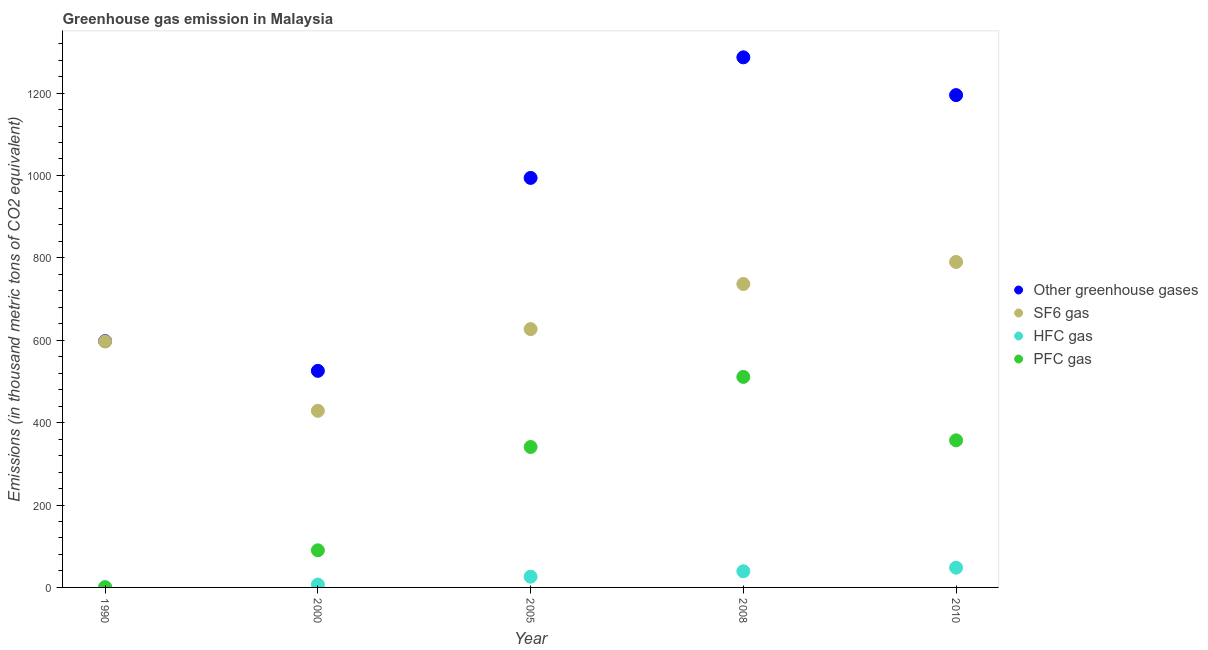What is the emission of greenhouse gases in 2005?
Your response must be concise. 994. Across all years, what is the maximum emission of greenhouse gases?
Provide a short and direct response. 1286.7. Across all years, what is the minimum emission of sf6 gas?
Your response must be concise. 428.7. What is the total emission of sf6 gas in the graph?
Your response must be concise. 3179.3. What is the difference between the emission of greenhouse gases in 2000 and that in 2010?
Keep it short and to the point. -669.3. What is the difference between the emission of hfc gas in 2000 and the emission of greenhouse gases in 2005?
Offer a terse response. -987.1. What is the average emission of hfc gas per year?
Your answer should be very brief. 24.06. In the year 2005, what is the difference between the emission of greenhouse gases and emission of hfc gas?
Offer a terse response. 967.9. What is the ratio of the emission of pfc gas in 2008 to that in 2010?
Your answer should be very brief. 1.43. What is the difference between the highest and the second highest emission of hfc gas?
Provide a short and direct response. 8.8. What is the difference between the highest and the lowest emission of hfc gas?
Your response must be concise. 47.9. Is the sum of the emission of pfc gas in 2008 and 2010 greater than the maximum emission of hfc gas across all years?
Offer a very short reply. Yes. Is it the case that in every year, the sum of the emission of pfc gas and emission of greenhouse gases is greater than the sum of emission of hfc gas and emission of sf6 gas?
Offer a very short reply. Yes. Is the emission of pfc gas strictly greater than the emission of sf6 gas over the years?
Provide a succinct answer. No. Is the emission of hfc gas strictly less than the emission of pfc gas over the years?
Your response must be concise. Yes. What is the difference between two consecutive major ticks on the Y-axis?
Provide a succinct answer. 200. Are the values on the major ticks of Y-axis written in scientific E-notation?
Your answer should be very brief. No. Does the graph contain any zero values?
Ensure brevity in your answer.  No. What is the title of the graph?
Give a very brief answer. Greenhouse gas emission in Malaysia. Does "Revenue mobilization" appear as one of the legend labels in the graph?
Keep it short and to the point. No. What is the label or title of the X-axis?
Make the answer very short. Year. What is the label or title of the Y-axis?
Give a very brief answer. Emissions (in thousand metric tons of CO2 equivalent). What is the Emissions (in thousand metric tons of CO2 equivalent) of Other greenhouse gases in 1990?
Keep it short and to the point. 597.8. What is the Emissions (in thousand metric tons of CO2 equivalent) of SF6 gas in 1990?
Offer a terse response. 597.1. What is the Emissions (in thousand metric tons of CO2 equivalent) in HFC gas in 1990?
Offer a terse response. 0.1. What is the Emissions (in thousand metric tons of CO2 equivalent) of PFC gas in 1990?
Offer a terse response. 0.6. What is the Emissions (in thousand metric tons of CO2 equivalent) of Other greenhouse gases in 2000?
Ensure brevity in your answer.  525.7. What is the Emissions (in thousand metric tons of CO2 equivalent) of SF6 gas in 2000?
Keep it short and to the point. 428.7. What is the Emissions (in thousand metric tons of CO2 equivalent) in PFC gas in 2000?
Provide a succinct answer. 90.1. What is the Emissions (in thousand metric tons of CO2 equivalent) in Other greenhouse gases in 2005?
Offer a terse response. 994. What is the Emissions (in thousand metric tons of CO2 equivalent) in SF6 gas in 2005?
Make the answer very short. 627. What is the Emissions (in thousand metric tons of CO2 equivalent) in HFC gas in 2005?
Your answer should be very brief. 26.1. What is the Emissions (in thousand metric tons of CO2 equivalent) in PFC gas in 2005?
Provide a succinct answer. 340.9. What is the Emissions (in thousand metric tons of CO2 equivalent) of Other greenhouse gases in 2008?
Your answer should be very brief. 1286.7. What is the Emissions (in thousand metric tons of CO2 equivalent) of SF6 gas in 2008?
Your answer should be very brief. 736.5. What is the Emissions (in thousand metric tons of CO2 equivalent) of HFC gas in 2008?
Offer a terse response. 39.2. What is the Emissions (in thousand metric tons of CO2 equivalent) in PFC gas in 2008?
Your answer should be compact. 511. What is the Emissions (in thousand metric tons of CO2 equivalent) of Other greenhouse gases in 2010?
Keep it short and to the point. 1195. What is the Emissions (in thousand metric tons of CO2 equivalent) in SF6 gas in 2010?
Make the answer very short. 790. What is the Emissions (in thousand metric tons of CO2 equivalent) in HFC gas in 2010?
Give a very brief answer. 48. What is the Emissions (in thousand metric tons of CO2 equivalent) in PFC gas in 2010?
Your answer should be compact. 357. Across all years, what is the maximum Emissions (in thousand metric tons of CO2 equivalent) of Other greenhouse gases?
Your response must be concise. 1286.7. Across all years, what is the maximum Emissions (in thousand metric tons of CO2 equivalent) of SF6 gas?
Offer a terse response. 790. Across all years, what is the maximum Emissions (in thousand metric tons of CO2 equivalent) in PFC gas?
Provide a short and direct response. 511. Across all years, what is the minimum Emissions (in thousand metric tons of CO2 equivalent) of Other greenhouse gases?
Offer a very short reply. 525.7. Across all years, what is the minimum Emissions (in thousand metric tons of CO2 equivalent) in SF6 gas?
Provide a succinct answer. 428.7. Across all years, what is the minimum Emissions (in thousand metric tons of CO2 equivalent) in HFC gas?
Your response must be concise. 0.1. Across all years, what is the minimum Emissions (in thousand metric tons of CO2 equivalent) of PFC gas?
Offer a terse response. 0.6. What is the total Emissions (in thousand metric tons of CO2 equivalent) of Other greenhouse gases in the graph?
Provide a short and direct response. 4599.2. What is the total Emissions (in thousand metric tons of CO2 equivalent) of SF6 gas in the graph?
Offer a very short reply. 3179.3. What is the total Emissions (in thousand metric tons of CO2 equivalent) in HFC gas in the graph?
Give a very brief answer. 120.3. What is the total Emissions (in thousand metric tons of CO2 equivalent) in PFC gas in the graph?
Provide a short and direct response. 1299.6. What is the difference between the Emissions (in thousand metric tons of CO2 equivalent) of Other greenhouse gases in 1990 and that in 2000?
Ensure brevity in your answer.  72.1. What is the difference between the Emissions (in thousand metric tons of CO2 equivalent) of SF6 gas in 1990 and that in 2000?
Give a very brief answer. 168.4. What is the difference between the Emissions (in thousand metric tons of CO2 equivalent) in HFC gas in 1990 and that in 2000?
Ensure brevity in your answer.  -6.8. What is the difference between the Emissions (in thousand metric tons of CO2 equivalent) in PFC gas in 1990 and that in 2000?
Ensure brevity in your answer.  -89.5. What is the difference between the Emissions (in thousand metric tons of CO2 equivalent) in Other greenhouse gases in 1990 and that in 2005?
Keep it short and to the point. -396.2. What is the difference between the Emissions (in thousand metric tons of CO2 equivalent) in SF6 gas in 1990 and that in 2005?
Offer a very short reply. -29.9. What is the difference between the Emissions (in thousand metric tons of CO2 equivalent) in HFC gas in 1990 and that in 2005?
Provide a short and direct response. -26. What is the difference between the Emissions (in thousand metric tons of CO2 equivalent) of PFC gas in 1990 and that in 2005?
Provide a succinct answer. -340.3. What is the difference between the Emissions (in thousand metric tons of CO2 equivalent) in Other greenhouse gases in 1990 and that in 2008?
Offer a terse response. -688.9. What is the difference between the Emissions (in thousand metric tons of CO2 equivalent) of SF6 gas in 1990 and that in 2008?
Keep it short and to the point. -139.4. What is the difference between the Emissions (in thousand metric tons of CO2 equivalent) in HFC gas in 1990 and that in 2008?
Give a very brief answer. -39.1. What is the difference between the Emissions (in thousand metric tons of CO2 equivalent) in PFC gas in 1990 and that in 2008?
Your answer should be compact. -510.4. What is the difference between the Emissions (in thousand metric tons of CO2 equivalent) in Other greenhouse gases in 1990 and that in 2010?
Offer a very short reply. -597.2. What is the difference between the Emissions (in thousand metric tons of CO2 equivalent) in SF6 gas in 1990 and that in 2010?
Make the answer very short. -192.9. What is the difference between the Emissions (in thousand metric tons of CO2 equivalent) of HFC gas in 1990 and that in 2010?
Keep it short and to the point. -47.9. What is the difference between the Emissions (in thousand metric tons of CO2 equivalent) of PFC gas in 1990 and that in 2010?
Provide a short and direct response. -356.4. What is the difference between the Emissions (in thousand metric tons of CO2 equivalent) in Other greenhouse gases in 2000 and that in 2005?
Provide a succinct answer. -468.3. What is the difference between the Emissions (in thousand metric tons of CO2 equivalent) of SF6 gas in 2000 and that in 2005?
Offer a terse response. -198.3. What is the difference between the Emissions (in thousand metric tons of CO2 equivalent) in HFC gas in 2000 and that in 2005?
Make the answer very short. -19.2. What is the difference between the Emissions (in thousand metric tons of CO2 equivalent) in PFC gas in 2000 and that in 2005?
Give a very brief answer. -250.8. What is the difference between the Emissions (in thousand metric tons of CO2 equivalent) of Other greenhouse gases in 2000 and that in 2008?
Provide a succinct answer. -761. What is the difference between the Emissions (in thousand metric tons of CO2 equivalent) in SF6 gas in 2000 and that in 2008?
Ensure brevity in your answer.  -307.8. What is the difference between the Emissions (in thousand metric tons of CO2 equivalent) of HFC gas in 2000 and that in 2008?
Keep it short and to the point. -32.3. What is the difference between the Emissions (in thousand metric tons of CO2 equivalent) of PFC gas in 2000 and that in 2008?
Make the answer very short. -420.9. What is the difference between the Emissions (in thousand metric tons of CO2 equivalent) of Other greenhouse gases in 2000 and that in 2010?
Your answer should be compact. -669.3. What is the difference between the Emissions (in thousand metric tons of CO2 equivalent) in SF6 gas in 2000 and that in 2010?
Offer a very short reply. -361.3. What is the difference between the Emissions (in thousand metric tons of CO2 equivalent) of HFC gas in 2000 and that in 2010?
Your answer should be very brief. -41.1. What is the difference between the Emissions (in thousand metric tons of CO2 equivalent) of PFC gas in 2000 and that in 2010?
Your answer should be very brief. -266.9. What is the difference between the Emissions (in thousand metric tons of CO2 equivalent) in Other greenhouse gases in 2005 and that in 2008?
Ensure brevity in your answer.  -292.7. What is the difference between the Emissions (in thousand metric tons of CO2 equivalent) of SF6 gas in 2005 and that in 2008?
Offer a very short reply. -109.5. What is the difference between the Emissions (in thousand metric tons of CO2 equivalent) in HFC gas in 2005 and that in 2008?
Offer a terse response. -13.1. What is the difference between the Emissions (in thousand metric tons of CO2 equivalent) of PFC gas in 2005 and that in 2008?
Offer a terse response. -170.1. What is the difference between the Emissions (in thousand metric tons of CO2 equivalent) of Other greenhouse gases in 2005 and that in 2010?
Your response must be concise. -201. What is the difference between the Emissions (in thousand metric tons of CO2 equivalent) of SF6 gas in 2005 and that in 2010?
Your response must be concise. -163. What is the difference between the Emissions (in thousand metric tons of CO2 equivalent) in HFC gas in 2005 and that in 2010?
Your answer should be very brief. -21.9. What is the difference between the Emissions (in thousand metric tons of CO2 equivalent) in PFC gas in 2005 and that in 2010?
Give a very brief answer. -16.1. What is the difference between the Emissions (in thousand metric tons of CO2 equivalent) in Other greenhouse gases in 2008 and that in 2010?
Your response must be concise. 91.7. What is the difference between the Emissions (in thousand metric tons of CO2 equivalent) in SF6 gas in 2008 and that in 2010?
Offer a terse response. -53.5. What is the difference between the Emissions (in thousand metric tons of CO2 equivalent) in PFC gas in 2008 and that in 2010?
Offer a terse response. 154. What is the difference between the Emissions (in thousand metric tons of CO2 equivalent) of Other greenhouse gases in 1990 and the Emissions (in thousand metric tons of CO2 equivalent) of SF6 gas in 2000?
Ensure brevity in your answer.  169.1. What is the difference between the Emissions (in thousand metric tons of CO2 equivalent) in Other greenhouse gases in 1990 and the Emissions (in thousand metric tons of CO2 equivalent) in HFC gas in 2000?
Your answer should be compact. 590.9. What is the difference between the Emissions (in thousand metric tons of CO2 equivalent) in Other greenhouse gases in 1990 and the Emissions (in thousand metric tons of CO2 equivalent) in PFC gas in 2000?
Provide a succinct answer. 507.7. What is the difference between the Emissions (in thousand metric tons of CO2 equivalent) of SF6 gas in 1990 and the Emissions (in thousand metric tons of CO2 equivalent) of HFC gas in 2000?
Your answer should be compact. 590.2. What is the difference between the Emissions (in thousand metric tons of CO2 equivalent) in SF6 gas in 1990 and the Emissions (in thousand metric tons of CO2 equivalent) in PFC gas in 2000?
Your response must be concise. 507. What is the difference between the Emissions (in thousand metric tons of CO2 equivalent) of HFC gas in 1990 and the Emissions (in thousand metric tons of CO2 equivalent) of PFC gas in 2000?
Give a very brief answer. -90. What is the difference between the Emissions (in thousand metric tons of CO2 equivalent) of Other greenhouse gases in 1990 and the Emissions (in thousand metric tons of CO2 equivalent) of SF6 gas in 2005?
Give a very brief answer. -29.2. What is the difference between the Emissions (in thousand metric tons of CO2 equivalent) of Other greenhouse gases in 1990 and the Emissions (in thousand metric tons of CO2 equivalent) of HFC gas in 2005?
Your response must be concise. 571.7. What is the difference between the Emissions (in thousand metric tons of CO2 equivalent) of Other greenhouse gases in 1990 and the Emissions (in thousand metric tons of CO2 equivalent) of PFC gas in 2005?
Offer a terse response. 256.9. What is the difference between the Emissions (in thousand metric tons of CO2 equivalent) in SF6 gas in 1990 and the Emissions (in thousand metric tons of CO2 equivalent) in HFC gas in 2005?
Ensure brevity in your answer.  571. What is the difference between the Emissions (in thousand metric tons of CO2 equivalent) of SF6 gas in 1990 and the Emissions (in thousand metric tons of CO2 equivalent) of PFC gas in 2005?
Provide a short and direct response. 256.2. What is the difference between the Emissions (in thousand metric tons of CO2 equivalent) in HFC gas in 1990 and the Emissions (in thousand metric tons of CO2 equivalent) in PFC gas in 2005?
Provide a succinct answer. -340.8. What is the difference between the Emissions (in thousand metric tons of CO2 equivalent) of Other greenhouse gases in 1990 and the Emissions (in thousand metric tons of CO2 equivalent) of SF6 gas in 2008?
Your answer should be very brief. -138.7. What is the difference between the Emissions (in thousand metric tons of CO2 equivalent) of Other greenhouse gases in 1990 and the Emissions (in thousand metric tons of CO2 equivalent) of HFC gas in 2008?
Give a very brief answer. 558.6. What is the difference between the Emissions (in thousand metric tons of CO2 equivalent) of Other greenhouse gases in 1990 and the Emissions (in thousand metric tons of CO2 equivalent) of PFC gas in 2008?
Make the answer very short. 86.8. What is the difference between the Emissions (in thousand metric tons of CO2 equivalent) in SF6 gas in 1990 and the Emissions (in thousand metric tons of CO2 equivalent) in HFC gas in 2008?
Your response must be concise. 557.9. What is the difference between the Emissions (in thousand metric tons of CO2 equivalent) in SF6 gas in 1990 and the Emissions (in thousand metric tons of CO2 equivalent) in PFC gas in 2008?
Your answer should be very brief. 86.1. What is the difference between the Emissions (in thousand metric tons of CO2 equivalent) in HFC gas in 1990 and the Emissions (in thousand metric tons of CO2 equivalent) in PFC gas in 2008?
Your answer should be very brief. -510.9. What is the difference between the Emissions (in thousand metric tons of CO2 equivalent) of Other greenhouse gases in 1990 and the Emissions (in thousand metric tons of CO2 equivalent) of SF6 gas in 2010?
Your answer should be compact. -192.2. What is the difference between the Emissions (in thousand metric tons of CO2 equivalent) of Other greenhouse gases in 1990 and the Emissions (in thousand metric tons of CO2 equivalent) of HFC gas in 2010?
Your answer should be compact. 549.8. What is the difference between the Emissions (in thousand metric tons of CO2 equivalent) of Other greenhouse gases in 1990 and the Emissions (in thousand metric tons of CO2 equivalent) of PFC gas in 2010?
Give a very brief answer. 240.8. What is the difference between the Emissions (in thousand metric tons of CO2 equivalent) of SF6 gas in 1990 and the Emissions (in thousand metric tons of CO2 equivalent) of HFC gas in 2010?
Make the answer very short. 549.1. What is the difference between the Emissions (in thousand metric tons of CO2 equivalent) in SF6 gas in 1990 and the Emissions (in thousand metric tons of CO2 equivalent) in PFC gas in 2010?
Offer a very short reply. 240.1. What is the difference between the Emissions (in thousand metric tons of CO2 equivalent) in HFC gas in 1990 and the Emissions (in thousand metric tons of CO2 equivalent) in PFC gas in 2010?
Your answer should be compact. -356.9. What is the difference between the Emissions (in thousand metric tons of CO2 equivalent) in Other greenhouse gases in 2000 and the Emissions (in thousand metric tons of CO2 equivalent) in SF6 gas in 2005?
Offer a terse response. -101.3. What is the difference between the Emissions (in thousand metric tons of CO2 equivalent) of Other greenhouse gases in 2000 and the Emissions (in thousand metric tons of CO2 equivalent) of HFC gas in 2005?
Provide a short and direct response. 499.6. What is the difference between the Emissions (in thousand metric tons of CO2 equivalent) of Other greenhouse gases in 2000 and the Emissions (in thousand metric tons of CO2 equivalent) of PFC gas in 2005?
Provide a succinct answer. 184.8. What is the difference between the Emissions (in thousand metric tons of CO2 equivalent) in SF6 gas in 2000 and the Emissions (in thousand metric tons of CO2 equivalent) in HFC gas in 2005?
Your answer should be compact. 402.6. What is the difference between the Emissions (in thousand metric tons of CO2 equivalent) in SF6 gas in 2000 and the Emissions (in thousand metric tons of CO2 equivalent) in PFC gas in 2005?
Your answer should be compact. 87.8. What is the difference between the Emissions (in thousand metric tons of CO2 equivalent) of HFC gas in 2000 and the Emissions (in thousand metric tons of CO2 equivalent) of PFC gas in 2005?
Make the answer very short. -334. What is the difference between the Emissions (in thousand metric tons of CO2 equivalent) of Other greenhouse gases in 2000 and the Emissions (in thousand metric tons of CO2 equivalent) of SF6 gas in 2008?
Make the answer very short. -210.8. What is the difference between the Emissions (in thousand metric tons of CO2 equivalent) in Other greenhouse gases in 2000 and the Emissions (in thousand metric tons of CO2 equivalent) in HFC gas in 2008?
Give a very brief answer. 486.5. What is the difference between the Emissions (in thousand metric tons of CO2 equivalent) of Other greenhouse gases in 2000 and the Emissions (in thousand metric tons of CO2 equivalent) of PFC gas in 2008?
Offer a terse response. 14.7. What is the difference between the Emissions (in thousand metric tons of CO2 equivalent) of SF6 gas in 2000 and the Emissions (in thousand metric tons of CO2 equivalent) of HFC gas in 2008?
Make the answer very short. 389.5. What is the difference between the Emissions (in thousand metric tons of CO2 equivalent) in SF6 gas in 2000 and the Emissions (in thousand metric tons of CO2 equivalent) in PFC gas in 2008?
Offer a very short reply. -82.3. What is the difference between the Emissions (in thousand metric tons of CO2 equivalent) in HFC gas in 2000 and the Emissions (in thousand metric tons of CO2 equivalent) in PFC gas in 2008?
Give a very brief answer. -504.1. What is the difference between the Emissions (in thousand metric tons of CO2 equivalent) of Other greenhouse gases in 2000 and the Emissions (in thousand metric tons of CO2 equivalent) of SF6 gas in 2010?
Provide a succinct answer. -264.3. What is the difference between the Emissions (in thousand metric tons of CO2 equivalent) of Other greenhouse gases in 2000 and the Emissions (in thousand metric tons of CO2 equivalent) of HFC gas in 2010?
Offer a very short reply. 477.7. What is the difference between the Emissions (in thousand metric tons of CO2 equivalent) in Other greenhouse gases in 2000 and the Emissions (in thousand metric tons of CO2 equivalent) in PFC gas in 2010?
Offer a very short reply. 168.7. What is the difference between the Emissions (in thousand metric tons of CO2 equivalent) in SF6 gas in 2000 and the Emissions (in thousand metric tons of CO2 equivalent) in HFC gas in 2010?
Make the answer very short. 380.7. What is the difference between the Emissions (in thousand metric tons of CO2 equivalent) of SF6 gas in 2000 and the Emissions (in thousand metric tons of CO2 equivalent) of PFC gas in 2010?
Provide a short and direct response. 71.7. What is the difference between the Emissions (in thousand metric tons of CO2 equivalent) of HFC gas in 2000 and the Emissions (in thousand metric tons of CO2 equivalent) of PFC gas in 2010?
Offer a very short reply. -350.1. What is the difference between the Emissions (in thousand metric tons of CO2 equivalent) of Other greenhouse gases in 2005 and the Emissions (in thousand metric tons of CO2 equivalent) of SF6 gas in 2008?
Give a very brief answer. 257.5. What is the difference between the Emissions (in thousand metric tons of CO2 equivalent) of Other greenhouse gases in 2005 and the Emissions (in thousand metric tons of CO2 equivalent) of HFC gas in 2008?
Make the answer very short. 954.8. What is the difference between the Emissions (in thousand metric tons of CO2 equivalent) in Other greenhouse gases in 2005 and the Emissions (in thousand metric tons of CO2 equivalent) in PFC gas in 2008?
Make the answer very short. 483. What is the difference between the Emissions (in thousand metric tons of CO2 equivalent) in SF6 gas in 2005 and the Emissions (in thousand metric tons of CO2 equivalent) in HFC gas in 2008?
Provide a short and direct response. 587.8. What is the difference between the Emissions (in thousand metric tons of CO2 equivalent) of SF6 gas in 2005 and the Emissions (in thousand metric tons of CO2 equivalent) of PFC gas in 2008?
Make the answer very short. 116. What is the difference between the Emissions (in thousand metric tons of CO2 equivalent) in HFC gas in 2005 and the Emissions (in thousand metric tons of CO2 equivalent) in PFC gas in 2008?
Keep it short and to the point. -484.9. What is the difference between the Emissions (in thousand metric tons of CO2 equivalent) in Other greenhouse gases in 2005 and the Emissions (in thousand metric tons of CO2 equivalent) in SF6 gas in 2010?
Provide a short and direct response. 204. What is the difference between the Emissions (in thousand metric tons of CO2 equivalent) in Other greenhouse gases in 2005 and the Emissions (in thousand metric tons of CO2 equivalent) in HFC gas in 2010?
Give a very brief answer. 946. What is the difference between the Emissions (in thousand metric tons of CO2 equivalent) in Other greenhouse gases in 2005 and the Emissions (in thousand metric tons of CO2 equivalent) in PFC gas in 2010?
Offer a very short reply. 637. What is the difference between the Emissions (in thousand metric tons of CO2 equivalent) of SF6 gas in 2005 and the Emissions (in thousand metric tons of CO2 equivalent) of HFC gas in 2010?
Provide a succinct answer. 579. What is the difference between the Emissions (in thousand metric tons of CO2 equivalent) of SF6 gas in 2005 and the Emissions (in thousand metric tons of CO2 equivalent) of PFC gas in 2010?
Keep it short and to the point. 270. What is the difference between the Emissions (in thousand metric tons of CO2 equivalent) in HFC gas in 2005 and the Emissions (in thousand metric tons of CO2 equivalent) in PFC gas in 2010?
Your answer should be very brief. -330.9. What is the difference between the Emissions (in thousand metric tons of CO2 equivalent) of Other greenhouse gases in 2008 and the Emissions (in thousand metric tons of CO2 equivalent) of SF6 gas in 2010?
Provide a succinct answer. 496.7. What is the difference between the Emissions (in thousand metric tons of CO2 equivalent) of Other greenhouse gases in 2008 and the Emissions (in thousand metric tons of CO2 equivalent) of HFC gas in 2010?
Ensure brevity in your answer.  1238.7. What is the difference between the Emissions (in thousand metric tons of CO2 equivalent) in Other greenhouse gases in 2008 and the Emissions (in thousand metric tons of CO2 equivalent) in PFC gas in 2010?
Provide a short and direct response. 929.7. What is the difference between the Emissions (in thousand metric tons of CO2 equivalent) of SF6 gas in 2008 and the Emissions (in thousand metric tons of CO2 equivalent) of HFC gas in 2010?
Provide a short and direct response. 688.5. What is the difference between the Emissions (in thousand metric tons of CO2 equivalent) of SF6 gas in 2008 and the Emissions (in thousand metric tons of CO2 equivalent) of PFC gas in 2010?
Your answer should be compact. 379.5. What is the difference between the Emissions (in thousand metric tons of CO2 equivalent) in HFC gas in 2008 and the Emissions (in thousand metric tons of CO2 equivalent) in PFC gas in 2010?
Give a very brief answer. -317.8. What is the average Emissions (in thousand metric tons of CO2 equivalent) in Other greenhouse gases per year?
Your response must be concise. 919.84. What is the average Emissions (in thousand metric tons of CO2 equivalent) in SF6 gas per year?
Keep it short and to the point. 635.86. What is the average Emissions (in thousand metric tons of CO2 equivalent) in HFC gas per year?
Your answer should be compact. 24.06. What is the average Emissions (in thousand metric tons of CO2 equivalent) of PFC gas per year?
Make the answer very short. 259.92. In the year 1990, what is the difference between the Emissions (in thousand metric tons of CO2 equivalent) of Other greenhouse gases and Emissions (in thousand metric tons of CO2 equivalent) of SF6 gas?
Your answer should be very brief. 0.7. In the year 1990, what is the difference between the Emissions (in thousand metric tons of CO2 equivalent) of Other greenhouse gases and Emissions (in thousand metric tons of CO2 equivalent) of HFC gas?
Keep it short and to the point. 597.7. In the year 1990, what is the difference between the Emissions (in thousand metric tons of CO2 equivalent) of Other greenhouse gases and Emissions (in thousand metric tons of CO2 equivalent) of PFC gas?
Ensure brevity in your answer.  597.2. In the year 1990, what is the difference between the Emissions (in thousand metric tons of CO2 equivalent) in SF6 gas and Emissions (in thousand metric tons of CO2 equivalent) in HFC gas?
Your response must be concise. 597. In the year 1990, what is the difference between the Emissions (in thousand metric tons of CO2 equivalent) in SF6 gas and Emissions (in thousand metric tons of CO2 equivalent) in PFC gas?
Your answer should be compact. 596.5. In the year 1990, what is the difference between the Emissions (in thousand metric tons of CO2 equivalent) in HFC gas and Emissions (in thousand metric tons of CO2 equivalent) in PFC gas?
Your answer should be very brief. -0.5. In the year 2000, what is the difference between the Emissions (in thousand metric tons of CO2 equivalent) in Other greenhouse gases and Emissions (in thousand metric tons of CO2 equivalent) in SF6 gas?
Make the answer very short. 97. In the year 2000, what is the difference between the Emissions (in thousand metric tons of CO2 equivalent) in Other greenhouse gases and Emissions (in thousand metric tons of CO2 equivalent) in HFC gas?
Your response must be concise. 518.8. In the year 2000, what is the difference between the Emissions (in thousand metric tons of CO2 equivalent) of Other greenhouse gases and Emissions (in thousand metric tons of CO2 equivalent) of PFC gas?
Your response must be concise. 435.6. In the year 2000, what is the difference between the Emissions (in thousand metric tons of CO2 equivalent) in SF6 gas and Emissions (in thousand metric tons of CO2 equivalent) in HFC gas?
Offer a terse response. 421.8. In the year 2000, what is the difference between the Emissions (in thousand metric tons of CO2 equivalent) of SF6 gas and Emissions (in thousand metric tons of CO2 equivalent) of PFC gas?
Keep it short and to the point. 338.6. In the year 2000, what is the difference between the Emissions (in thousand metric tons of CO2 equivalent) in HFC gas and Emissions (in thousand metric tons of CO2 equivalent) in PFC gas?
Keep it short and to the point. -83.2. In the year 2005, what is the difference between the Emissions (in thousand metric tons of CO2 equivalent) of Other greenhouse gases and Emissions (in thousand metric tons of CO2 equivalent) of SF6 gas?
Offer a terse response. 367. In the year 2005, what is the difference between the Emissions (in thousand metric tons of CO2 equivalent) in Other greenhouse gases and Emissions (in thousand metric tons of CO2 equivalent) in HFC gas?
Your answer should be compact. 967.9. In the year 2005, what is the difference between the Emissions (in thousand metric tons of CO2 equivalent) in Other greenhouse gases and Emissions (in thousand metric tons of CO2 equivalent) in PFC gas?
Offer a very short reply. 653.1. In the year 2005, what is the difference between the Emissions (in thousand metric tons of CO2 equivalent) of SF6 gas and Emissions (in thousand metric tons of CO2 equivalent) of HFC gas?
Offer a terse response. 600.9. In the year 2005, what is the difference between the Emissions (in thousand metric tons of CO2 equivalent) of SF6 gas and Emissions (in thousand metric tons of CO2 equivalent) of PFC gas?
Make the answer very short. 286.1. In the year 2005, what is the difference between the Emissions (in thousand metric tons of CO2 equivalent) in HFC gas and Emissions (in thousand metric tons of CO2 equivalent) in PFC gas?
Your answer should be compact. -314.8. In the year 2008, what is the difference between the Emissions (in thousand metric tons of CO2 equivalent) of Other greenhouse gases and Emissions (in thousand metric tons of CO2 equivalent) of SF6 gas?
Keep it short and to the point. 550.2. In the year 2008, what is the difference between the Emissions (in thousand metric tons of CO2 equivalent) of Other greenhouse gases and Emissions (in thousand metric tons of CO2 equivalent) of HFC gas?
Provide a short and direct response. 1247.5. In the year 2008, what is the difference between the Emissions (in thousand metric tons of CO2 equivalent) of Other greenhouse gases and Emissions (in thousand metric tons of CO2 equivalent) of PFC gas?
Ensure brevity in your answer.  775.7. In the year 2008, what is the difference between the Emissions (in thousand metric tons of CO2 equivalent) in SF6 gas and Emissions (in thousand metric tons of CO2 equivalent) in HFC gas?
Give a very brief answer. 697.3. In the year 2008, what is the difference between the Emissions (in thousand metric tons of CO2 equivalent) in SF6 gas and Emissions (in thousand metric tons of CO2 equivalent) in PFC gas?
Provide a succinct answer. 225.5. In the year 2008, what is the difference between the Emissions (in thousand metric tons of CO2 equivalent) in HFC gas and Emissions (in thousand metric tons of CO2 equivalent) in PFC gas?
Keep it short and to the point. -471.8. In the year 2010, what is the difference between the Emissions (in thousand metric tons of CO2 equivalent) in Other greenhouse gases and Emissions (in thousand metric tons of CO2 equivalent) in SF6 gas?
Offer a terse response. 405. In the year 2010, what is the difference between the Emissions (in thousand metric tons of CO2 equivalent) of Other greenhouse gases and Emissions (in thousand metric tons of CO2 equivalent) of HFC gas?
Offer a terse response. 1147. In the year 2010, what is the difference between the Emissions (in thousand metric tons of CO2 equivalent) of Other greenhouse gases and Emissions (in thousand metric tons of CO2 equivalent) of PFC gas?
Give a very brief answer. 838. In the year 2010, what is the difference between the Emissions (in thousand metric tons of CO2 equivalent) of SF6 gas and Emissions (in thousand metric tons of CO2 equivalent) of HFC gas?
Give a very brief answer. 742. In the year 2010, what is the difference between the Emissions (in thousand metric tons of CO2 equivalent) in SF6 gas and Emissions (in thousand metric tons of CO2 equivalent) in PFC gas?
Provide a succinct answer. 433. In the year 2010, what is the difference between the Emissions (in thousand metric tons of CO2 equivalent) of HFC gas and Emissions (in thousand metric tons of CO2 equivalent) of PFC gas?
Keep it short and to the point. -309. What is the ratio of the Emissions (in thousand metric tons of CO2 equivalent) of Other greenhouse gases in 1990 to that in 2000?
Offer a very short reply. 1.14. What is the ratio of the Emissions (in thousand metric tons of CO2 equivalent) in SF6 gas in 1990 to that in 2000?
Offer a terse response. 1.39. What is the ratio of the Emissions (in thousand metric tons of CO2 equivalent) in HFC gas in 1990 to that in 2000?
Keep it short and to the point. 0.01. What is the ratio of the Emissions (in thousand metric tons of CO2 equivalent) of PFC gas in 1990 to that in 2000?
Keep it short and to the point. 0.01. What is the ratio of the Emissions (in thousand metric tons of CO2 equivalent) of Other greenhouse gases in 1990 to that in 2005?
Your response must be concise. 0.6. What is the ratio of the Emissions (in thousand metric tons of CO2 equivalent) in SF6 gas in 1990 to that in 2005?
Offer a very short reply. 0.95. What is the ratio of the Emissions (in thousand metric tons of CO2 equivalent) in HFC gas in 1990 to that in 2005?
Your answer should be compact. 0. What is the ratio of the Emissions (in thousand metric tons of CO2 equivalent) of PFC gas in 1990 to that in 2005?
Your response must be concise. 0. What is the ratio of the Emissions (in thousand metric tons of CO2 equivalent) in Other greenhouse gases in 1990 to that in 2008?
Your answer should be compact. 0.46. What is the ratio of the Emissions (in thousand metric tons of CO2 equivalent) of SF6 gas in 1990 to that in 2008?
Provide a short and direct response. 0.81. What is the ratio of the Emissions (in thousand metric tons of CO2 equivalent) in HFC gas in 1990 to that in 2008?
Provide a short and direct response. 0. What is the ratio of the Emissions (in thousand metric tons of CO2 equivalent) of PFC gas in 1990 to that in 2008?
Provide a short and direct response. 0. What is the ratio of the Emissions (in thousand metric tons of CO2 equivalent) of Other greenhouse gases in 1990 to that in 2010?
Offer a terse response. 0.5. What is the ratio of the Emissions (in thousand metric tons of CO2 equivalent) in SF6 gas in 1990 to that in 2010?
Ensure brevity in your answer.  0.76. What is the ratio of the Emissions (in thousand metric tons of CO2 equivalent) in HFC gas in 1990 to that in 2010?
Offer a very short reply. 0. What is the ratio of the Emissions (in thousand metric tons of CO2 equivalent) of PFC gas in 1990 to that in 2010?
Keep it short and to the point. 0. What is the ratio of the Emissions (in thousand metric tons of CO2 equivalent) of Other greenhouse gases in 2000 to that in 2005?
Your answer should be compact. 0.53. What is the ratio of the Emissions (in thousand metric tons of CO2 equivalent) in SF6 gas in 2000 to that in 2005?
Provide a short and direct response. 0.68. What is the ratio of the Emissions (in thousand metric tons of CO2 equivalent) in HFC gas in 2000 to that in 2005?
Provide a succinct answer. 0.26. What is the ratio of the Emissions (in thousand metric tons of CO2 equivalent) of PFC gas in 2000 to that in 2005?
Offer a very short reply. 0.26. What is the ratio of the Emissions (in thousand metric tons of CO2 equivalent) in Other greenhouse gases in 2000 to that in 2008?
Ensure brevity in your answer.  0.41. What is the ratio of the Emissions (in thousand metric tons of CO2 equivalent) in SF6 gas in 2000 to that in 2008?
Offer a terse response. 0.58. What is the ratio of the Emissions (in thousand metric tons of CO2 equivalent) of HFC gas in 2000 to that in 2008?
Offer a terse response. 0.18. What is the ratio of the Emissions (in thousand metric tons of CO2 equivalent) of PFC gas in 2000 to that in 2008?
Provide a succinct answer. 0.18. What is the ratio of the Emissions (in thousand metric tons of CO2 equivalent) of Other greenhouse gases in 2000 to that in 2010?
Keep it short and to the point. 0.44. What is the ratio of the Emissions (in thousand metric tons of CO2 equivalent) of SF6 gas in 2000 to that in 2010?
Your response must be concise. 0.54. What is the ratio of the Emissions (in thousand metric tons of CO2 equivalent) in HFC gas in 2000 to that in 2010?
Provide a succinct answer. 0.14. What is the ratio of the Emissions (in thousand metric tons of CO2 equivalent) in PFC gas in 2000 to that in 2010?
Ensure brevity in your answer.  0.25. What is the ratio of the Emissions (in thousand metric tons of CO2 equivalent) in Other greenhouse gases in 2005 to that in 2008?
Offer a very short reply. 0.77. What is the ratio of the Emissions (in thousand metric tons of CO2 equivalent) in SF6 gas in 2005 to that in 2008?
Provide a short and direct response. 0.85. What is the ratio of the Emissions (in thousand metric tons of CO2 equivalent) of HFC gas in 2005 to that in 2008?
Your answer should be very brief. 0.67. What is the ratio of the Emissions (in thousand metric tons of CO2 equivalent) in PFC gas in 2005 to that in 2008?
Your response must be concise. 0.67. What is the ratio of the Emissions (in thousand metric tons of CO2 equivalent) in Other greenhouse gases in 2005 to that in 2010?
Keep it short and to the point. 0.83. What is the ratio of the Emissions (in thousand metric tons of CO2 equivalent) in SF6 gas in 2005 to that in 2010?
Offer a terse response. 0.79. What is the ratio of the Emissions (in thousand metric tons of CO2 equivalent) in HFC gas in 2005 to that in 2010?
Provide a short and direct response. 0.54. What is the ratio of the Emissions (in thousand metric tons of CO2 equivalent) of PFC gas in 2005 to that in 2010?
Your answer should be compact. 0.95. What is the ratio of the Emissions (in thousand metric tons of CO2 equivalent) of Other greenhouse gases in 2008 to that in 2010?
Make the answer very short. 1.08. What is the ratio of the Emissions (in thousand metric tons of CO2 equivalent) in SF6 gas in 2008 to that in 2010?
Provide a short and direct response. 0.93. What is the ratio of the Emissions (in thousand metric tons of CO2 equivalent) of HFC gas in 2008 to that in 2010?
Give a very brief answer. 0.82. What is the ratio of the Emissions (in thousand metric tons of CO2 equivalent) in PFC gas in 2008 to that in 2010?
Provide a short and direct response. 1.43. What is the difference between the highest and the second highest Emissions (in thousand metric tons of CO2 equivalent) in Other greenhouse gases?
Offer a terse response. 91.7. What is the difference between the highest and the second highest Emissions (in thousand metric tons of CO2 equivalent) of SF6 gas?
Your answer should be very brief. 53.5. What is the difference between the highest and the second highest Emissions (in thousand metric tons of CO2 equivalent) of PFC gas?
Your answer should be very brief. 154. What is the difference between the highest and the lowest Emissions (in thousand metric tons of CO2 equivalent) in Other greenhouse gases?
Provide a succinct answer. 761. What is the difference between the highest and the lowest Emissions (in thousand metric tons of CO2 equivalent) of SF6 gas?
Ensure brevity in your answer.  361.3. What is the difference between the highest and the lowest Emissions (in thousand metric tons of CO2 equivalent) of HFC gas?
Keep it short and to the point. 47.9. What is the difference between the highest and the lowest Emissions (in thousand metric tons of CO2 equivalent) in PFC gas?
Keep it short and to the point. 510.4. 